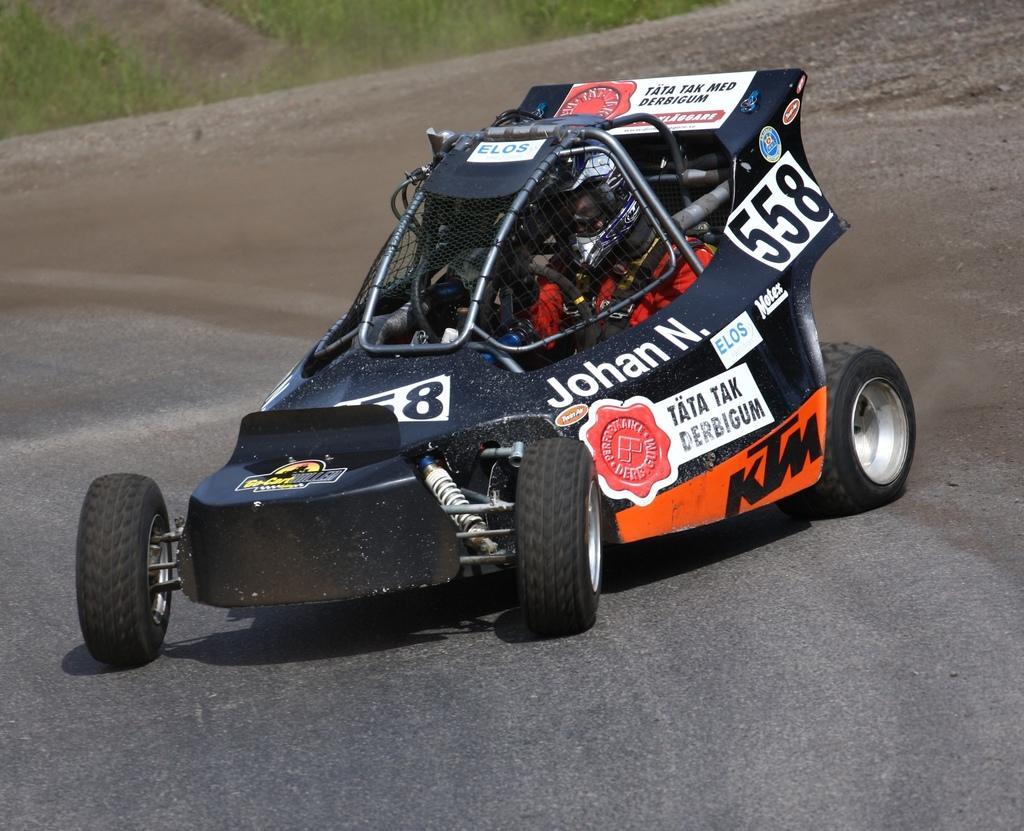How would you summarize this image in a sentence or two? This image consists of a sports car in black color. At the bottom, there is a road. In the background, we can see green grass. 